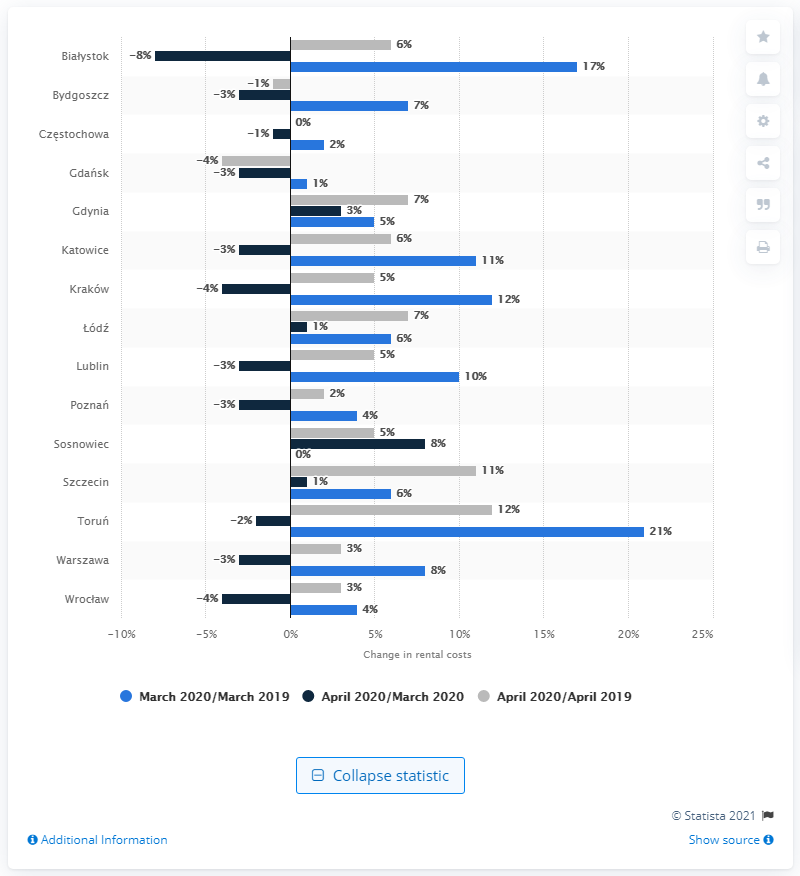Highlight a few significant elements in this photo. In Sosnowiec, rental costs dropped by seven percent. 